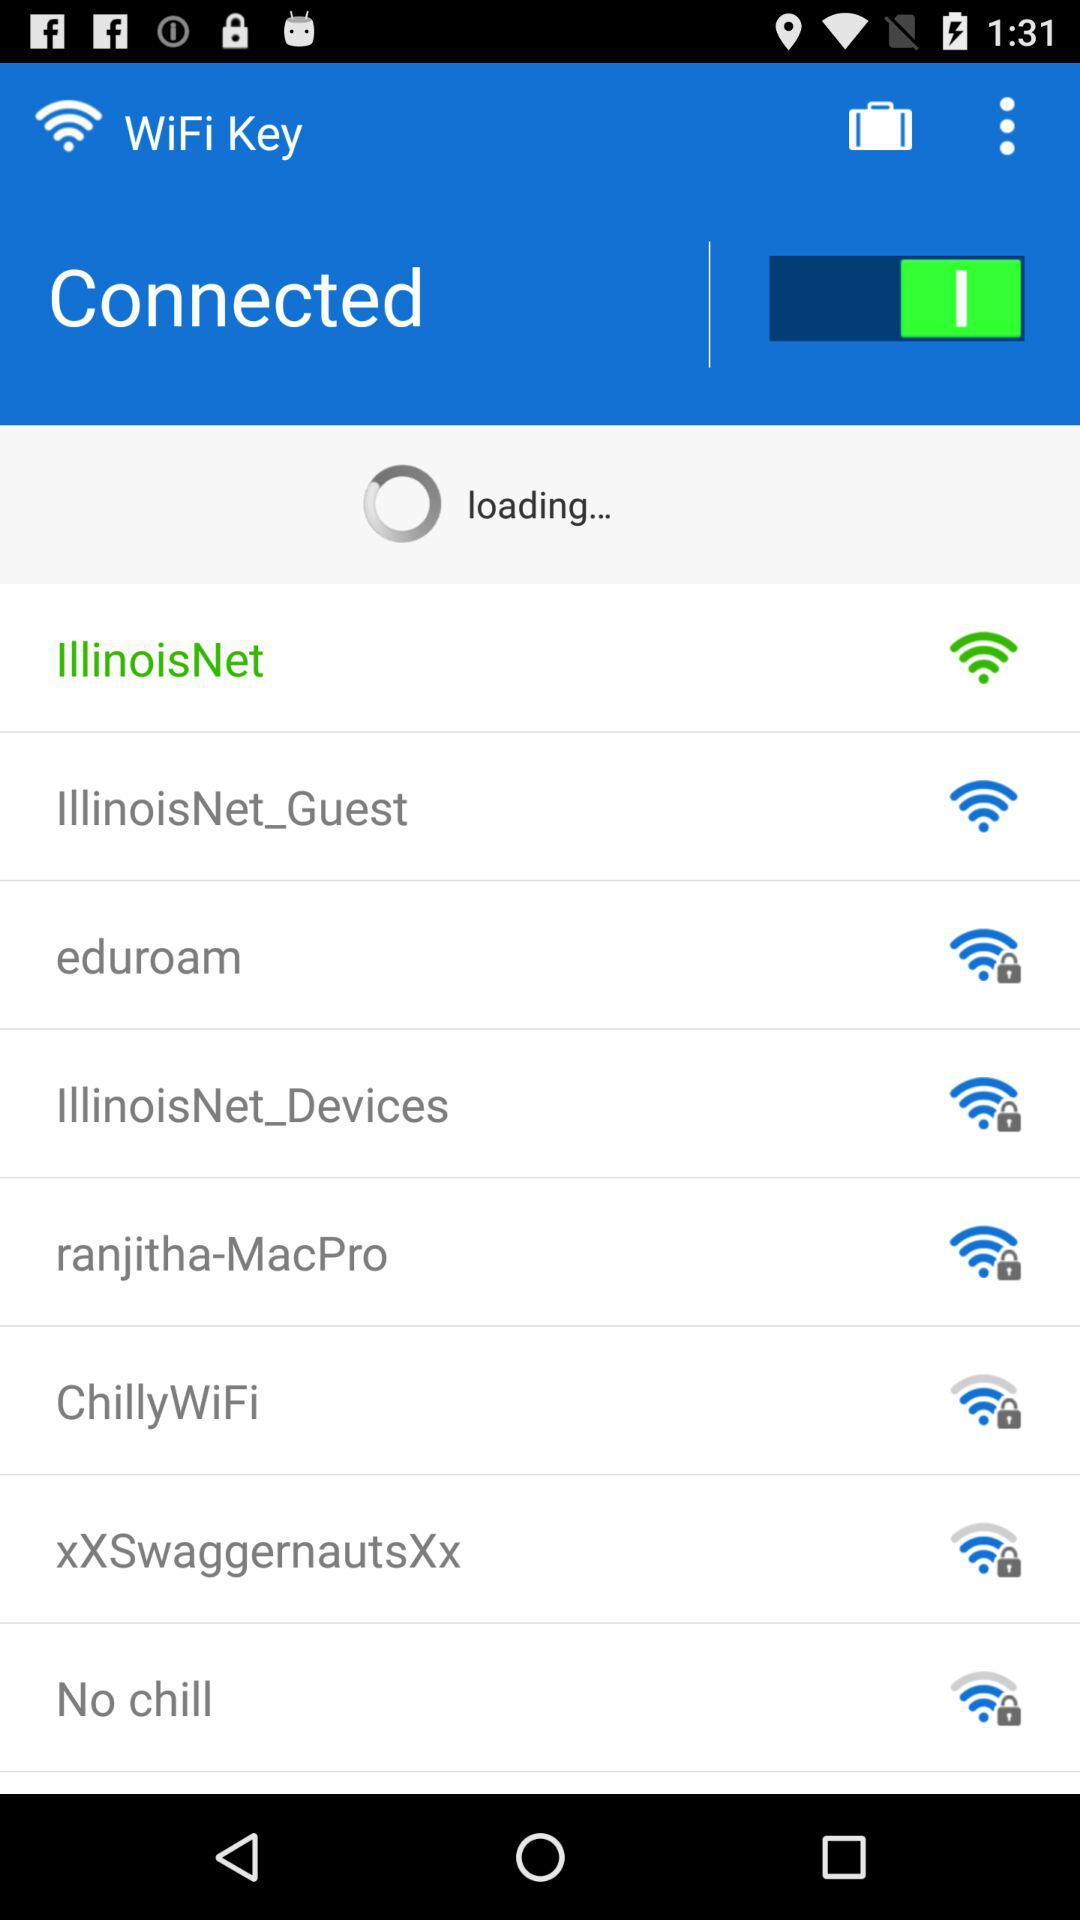How many Wi-Fi networks are there?
Answer the question using a single word or phrase. 8 